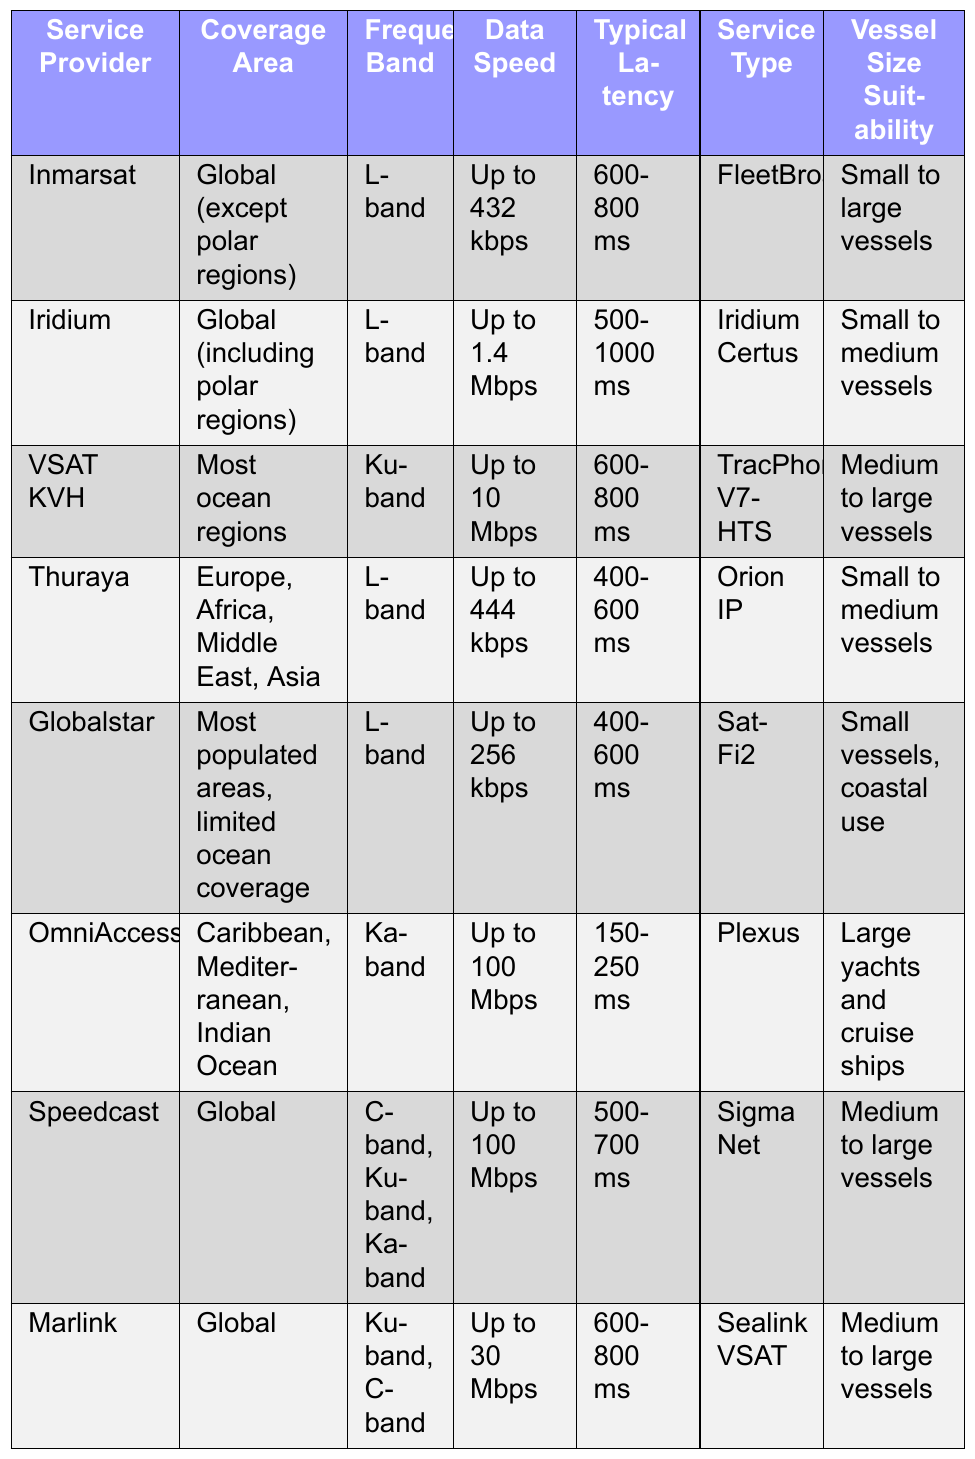What is the coverage area of Iridium? According to the table, Iridium's coverage area is specified as "Global (including polar regions)."
Answer: Global (including polar regions) Which service provider offers the highest data speed? The table indicates that OmniAccess and Speedcast both offer the highest data speeds of "Up to 100 Mbps."
Answer: OmniAccess and Speedcast Is the frequency band used by Globalstar L-band or Ku-band? The information in the table shows that Globalstar uses the L-band frequency.
Answer: L-band What is the typical latency of VSAT KVH service? The table lists the typical latency for VSAT KVH as "600-800 ms."
Answer: 600-800 ms Which service type is suitable for large yachts and cruise ships? According to the table, the service type suitable for large yachts and cruise ships is "Plexus."
Answer: Plexus Are Iridium and Thuraya both suitable for small vessels? The table shows that Iridium is suitable for "Small to medium vessels," while Thuraya is suitable for "Small to medium vessels," making the statement true.
Answer: Yes Which service providers have coverage in Europe? By examining the coverage areas in the table, only Thuraya clearly lists "Europe," while others generally cover broader areas or are global.
Answer: Thuraya How does the typical latency of OmniAccess compare to that of Globalstar? The typical latency for OmniAccess is "150-250 ms," while Globalstar's typical latency is "400-600 ms." Since 150-250 ms is less than 400-600 ms, OmniAccess has lower latency.
Answer: OmniAccess has lower latency Which service provider uses Ka-band frequency? The table lists OmniAccess as the service provider that uses a Ka-band frequency.
Answer: OmniAccess If I have a medium vessel, which service providers are suitable for me? The table shows that Iridium, VSAT KVH, Speedcast, and Marlink are suitable for medium vessels, based on their respective listings.
Answer: Iridium, VSAT KVH, Speedcast, Marlink What is the average data speed of all service providers listed? The data speeds are: 432 kbps, 1.4 Mbps, 10 Mbps, 444 kbps, 256 kbps, 100 Mbps, 100 Mbps, and 30 Mbps. Converting to Mbps: 0.432, 1.4, 10, 0.444, 0.256, 100, 100, and 30. The sum is 242.572 Mbps and there are 8 entries, so dividing gives us an average of 30.32 Mbps.
Answer: 30.32 Mbps 